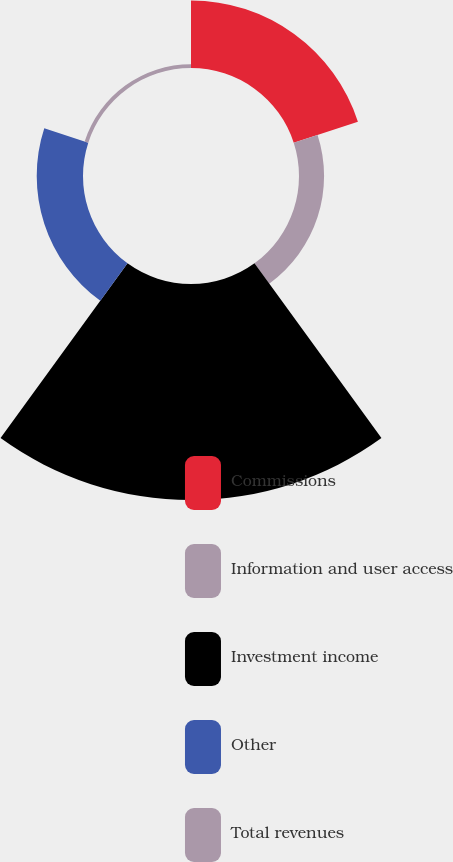Convert chart to OTSL. <chart><loc_0><loc_0><loc_500><loc_500><pie_chart><fcel>Commissions<fcel>Information and user access<fcel>Investment income<fcel>Other<fcel>Total revenues<nl><fcel>18.82%<fcel>6.99%<fcel>60.22%<fcel>12.9%<fcel>1.07%<nl></chart> 